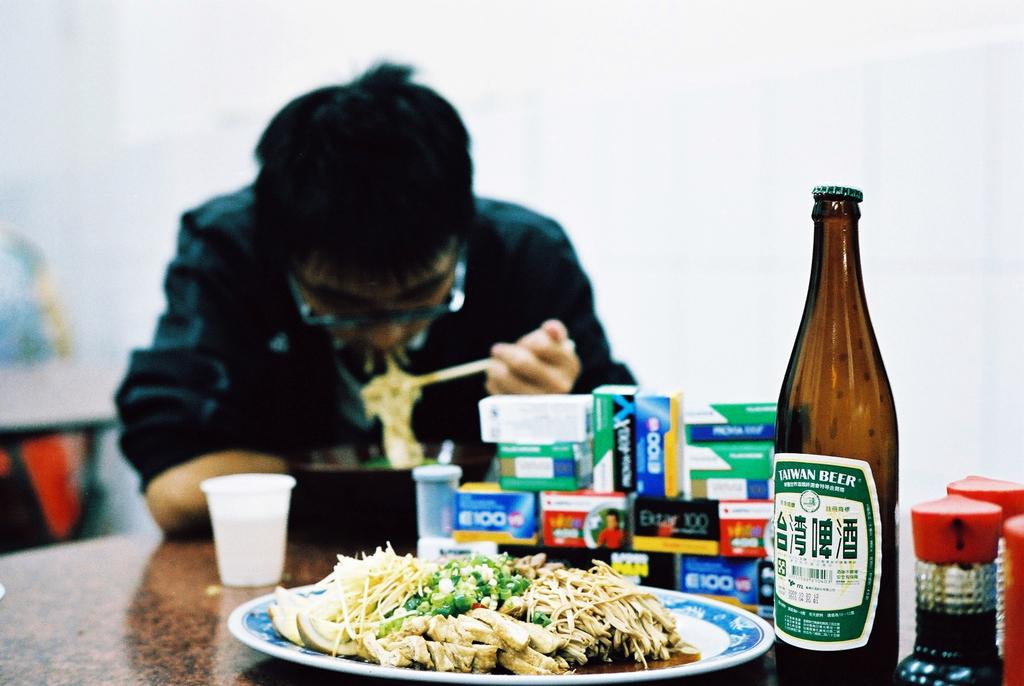<image>
Describe the image concisely. a person sitting near some Taiwan beer that is close 